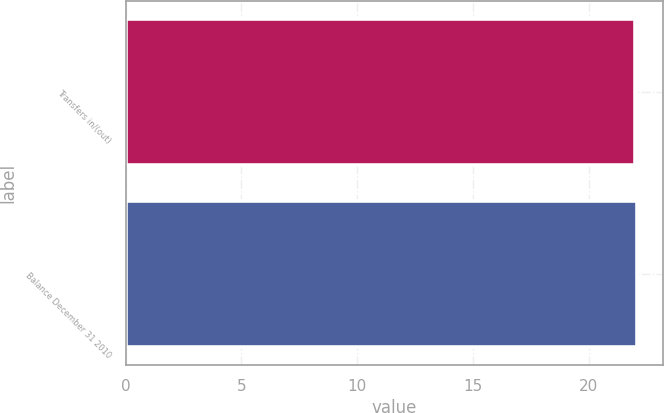Convert chart to OTSL. <chart><loc_0><loc_0><loc_500><loc_500><bar_chart><fcel>Transfers in/(out)<fcel>Balance December 31 2010<nl><fcel>22<fcel>22.1<nl></chart> 